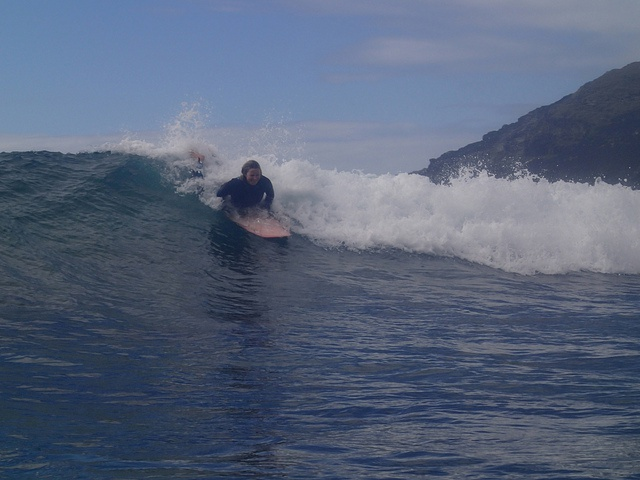Describe the objects in this image and their specific colors. I can see people in gray, navy, black, and purple tones and surfboard in gray and black tones in this image. 